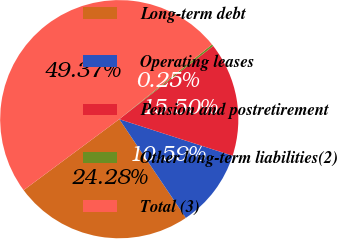Convert chart to OTSL. <chart><loc_0><loc_0><loc_500><loc_500><pie_chart><fcel>Long-term debt<fcel>Operating leases<fcel>Pension and postretirement<fcel>Other long-term liabilities(2)<fcel>Total (3)<nl><fcel>24.28%<fcel>10.59%<fcel>15.5%<fcel>0.25%<fcel>49.37%<nl></chart> 